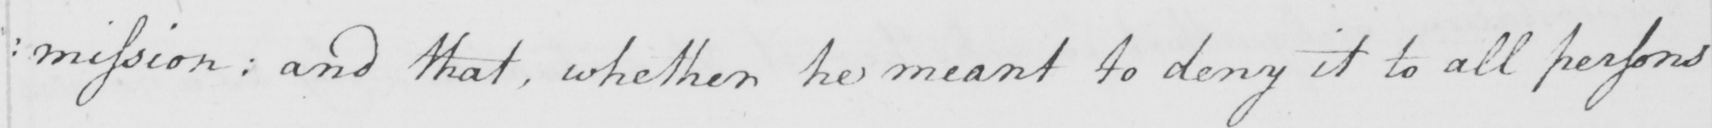Transcribe the text shown in this historical manuscript line. : mission and that , whether he meant to deny it to all persons 